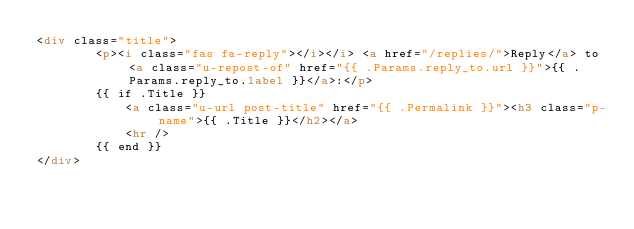Convert code to text. <code><loc_0><loc_0><loc_500><loc_500><_HTML_><div class="title">
        <p><i class="fas fa-reply"></i></i> <a href="/replies/">Reply</a> to <a class="u-repost-of" href="{{ .Params.reply_to.url }}">{{ .Params.reply_to.label }}</a>:</p>
        {{ if .Title }}
            <a class="u-url post-title" href="{{ .Permalink }}"><h3 class="p-name">{{ .Title }}</h2></a>
            <hr />
        {{ end }}
</div>
</code> 